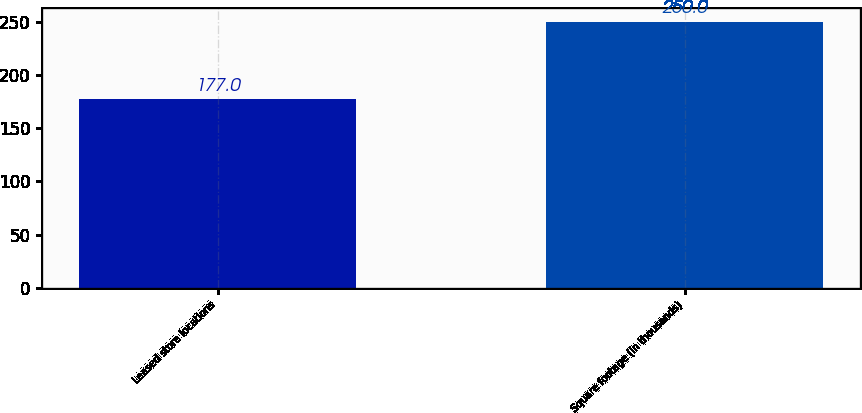<chart> <loc_0><loc_0><loc_500><loc_500><bar_chart><fcel>Leased store locations<fcel>Square footage (in thousands)<nl><fcel>177<fcel>250<nl></chart> 